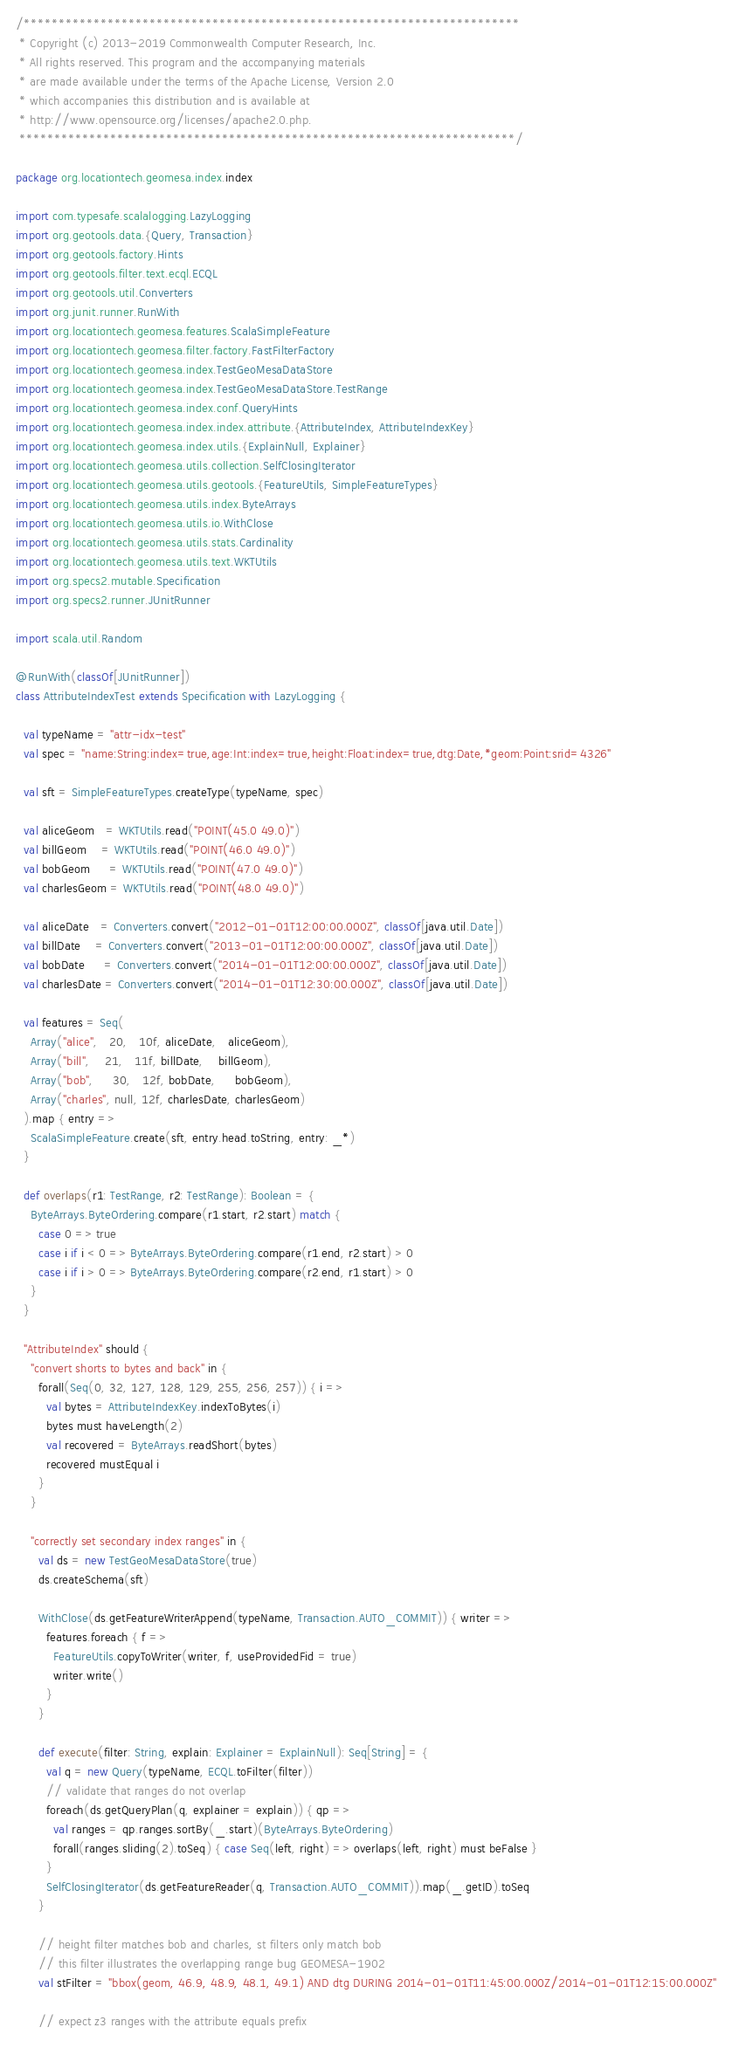Convert code to text. <code><loc_0><loc_0><loc_500><loc_500><_Scala_>/***********************************************************************
 * Copyright (c) 2013-2019 Commonwealth Computer Research, Inc.
 * All rights reserved. This program and the accompanying materials
 * are made available under the terms of the Apache License, Version 2.0
 * which accompanies this distribution and is available at
 * http://www.opensource.org/licenses/apache2.0.php.
 ***********************************************************************/

package org.locationtech.geomesa.index.index

import com.typesafe.scalalogging.LazyLogging
import org.geotools.data.{Query, Transaction}
import org.geotools.factory.Hints
import org.geotools.filter.text.ecql.ECQL
import org.geotools.util.Converters
import org.junit.runner.RunWith
import org.locationtech.geomesa.features.ScalaSimpleFeature
import org.locationtech.geomesa.filter.factory.FastFilterFactory
import org.locationtech.geomesa.index.TestGeoMesaDataStore
import org.locationtech.geomesa.index.TestGeoMesaDataStore.TestRange
import org.locationtech.geomesa.index.conf.QueryHints
import org.locationtech.geomesa.index.index.attribute.{AttributeIndex, AttributeIndexKey}
import org.locationtech.geomesa.index.utils.{ExplainNull, Explainer}
import org.locationtech.geomesa.utils.collection.SelfClosingIterator
import org.locationtech.geomesa.utils.geotools.{FeatureUtils, SimpleFeatureTypes}
import org.locationtech.geomesa.utils.index.ByteArrays
import org.locationtech.geomesa.utils.io.WithClose
import org.locationtech.geomesa.utils.stats.Cardinality
import org.locationtech.geomesa.utils.text.WKTUtils
import org.specs2.mutable.Specification
import org.specs2.runner.JUnitRunner

import scala.util.Random

@RunWith(classOf[JUnitRunner])
class AttributeIndexTest extends Specification with LazyLogging {

  val typeName = "attr-idx-test"
  val spec = "name:String:index=true,age:Int:index=true,height:Float:index=true,dtg:Date,*geom:Point:srid=4326"

  val sft = SimpleFeatureTypes.createType(typeName, spec)

  val aliceGeom   = WKTUtils.read("POINT(45.0 49.0)")
  val billGeom    = WKTUtils.read("POINT(46.0 49.0)")
  val bobGeom     = WKTUtils.read("POINT(47.0 49.0)")
  val charlesGeom = WKTUtils.read("POINT(48.0 49.0)")

  val aliceDate   = Converters.convert("2012-01-01T12:00:00.000Z", classOf[java.util.Date])
  val billDate    = Converters.convert("2013-01-01T12:00:00.000Z", classOf[java.util.Date])
  val bobDate     = Converters.convert("2014-01-01T12:00:00.000Z", classOf[java.util.Date])
  val charlesDate = Converters.convert("2014-01-01T12:30:00.000Z", classOf[java.util.Date])

  val features = Seq(
    Array("alice",   20,   10f, aliceDate,   aliceGeom),
    Array("bill",    21,   11f, billDate,    billGeom),
    Array("bob",     30,   12f, bobDate,     bobGeom),
    Array("charles", null, 12f, charlesDate, charlesGeom)
  ).map { entry =>
    ScalaSimpleFeature.create(sft, entry.head.toString, entry: _*)
  }

  def overlaps(r1: TestRange, r2: TestRange): Boolean = {
    ByteArrays.ByteOrdering.compare(r1.start, r2.start) match {
      case 0 => true
      case i if i < 0 => ByteArrays.ByteOrdering.compare(r1.end, r2.start) > 0
      case i if i > 0 => ByteArrays.ByteOrdering.compare(r2.end, r1.start) > 0
    }
  }

  "AttributeIndex" should {
    "convert shorts to bytes and back" in {
      forall(Seq(0, 32, 127, 128, 129, 255, 256, 257)) { i =>
        val bytes = AttributeIndexKey.indexToBytes(i)
        bytes must haveLength(2)
        val recovered = ByteArrays.readShort(bytes)
        recovered mustEqual i
      }
    }

    "correctly set secondary index ranges" in {
      val ds = new TestGeoMesaDataStore(true)
      ds.createSchema(sft)

      WithClose(ds.getFeatureWriterAppend(typeName, Transaction.AUTO_COMMIT)) { writer =>
        features.foreach { f =>
          FeatureUtils.copyToWriter(writer, f, useProvidedFid = true)
          writer.write()
        }
      }

      def execute(filter: String, explain: Explainer = ExplainNull): Seq[String] = {
        val q = new Query(typeName, ECQL.toFilter(filter))
        // validate that ranges do not overlap
        foreach(ds.getQueryPlan(q, explainer = explain)) { qp =>
          val ranges = qp.ranges.sortBy(_.start)(ByteArrays.ByteOrdering)
          forall(ranges.sliding(2).toSeq) { case Seq(left, right) => overlaps(left, right) must beFalse }
        }
        SelfClosingIterator(ds.getFeatureReader(q, Transaction.AUTO_COMMIT)).map(_.getID).toSeq
      }

      // height filter matches bob and charles, st filters only match bob
      // this filter illustrates the overlapping range bug GEOMESA-1902
      val stFilter = "bbox(geom, 46.9, 48.9, 48.1, 49.1) AND dtg DURING 2014-01-01T11:45:00.000Z/2014-01-01T12:15:00.000Z"

      // expect z3 ranges with the attribute equals prefix</code> 